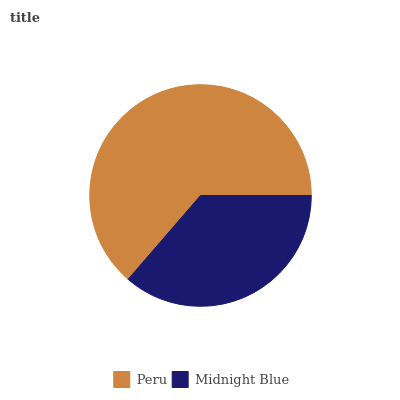Is Midnight Blue the minimum?
Answer yes or no. Yes. Is Peru the maximum?
Answer yes or no. Yes. Is Midnight Blue the maximum?
Answer yes or no. No. Is Peru greater than Midnight Blue?
Answer yes or no. Yes. Is Midnight Blue less than Peru?
Answer yes or no. Yes. Is Midnight Blue greater than Peru?
Answer yes or no. No. Is Peru less than Midnight Blue?
Answer yes or no. No. Is Peru the high median?
Answer yes or no. Yes. Is Midnight Blue the low median?
Answer yes or no. Yes. Is Midnight Blue the high median?
Answer yes or no. No. Is Peru the low median?
Answer yes or no. No. 